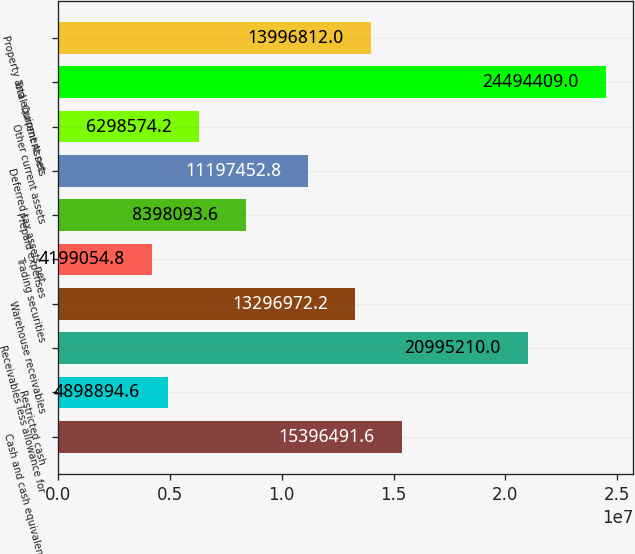Convert chart. <chart><loc_0><loc_0><loc_500><loc_500><bar_chart><fcel>Cash and cash equivalents<fcel>Restricted cash<fcel>Receivables less allowance for<fcel>Warehouse receivables<fcel>Trading securities<fcel>Prepaid expenses<fcel>Deferred tax assets net<fcel>Other current assets<fcel>Total Current Assets<fcel>Property and equipment net<nl><fcel>1.53965e+07<fcel>4.89889e+06<fcel>2.09952e+07<fcel>1.3297e+07<fcel>4.19905e+06<fcel>8.39809e+06<fcel>1.11975e+07<fcel>6.29857e+06<fcel>2.44944e+07<fcel>1.39968e+07<nl></chart> 